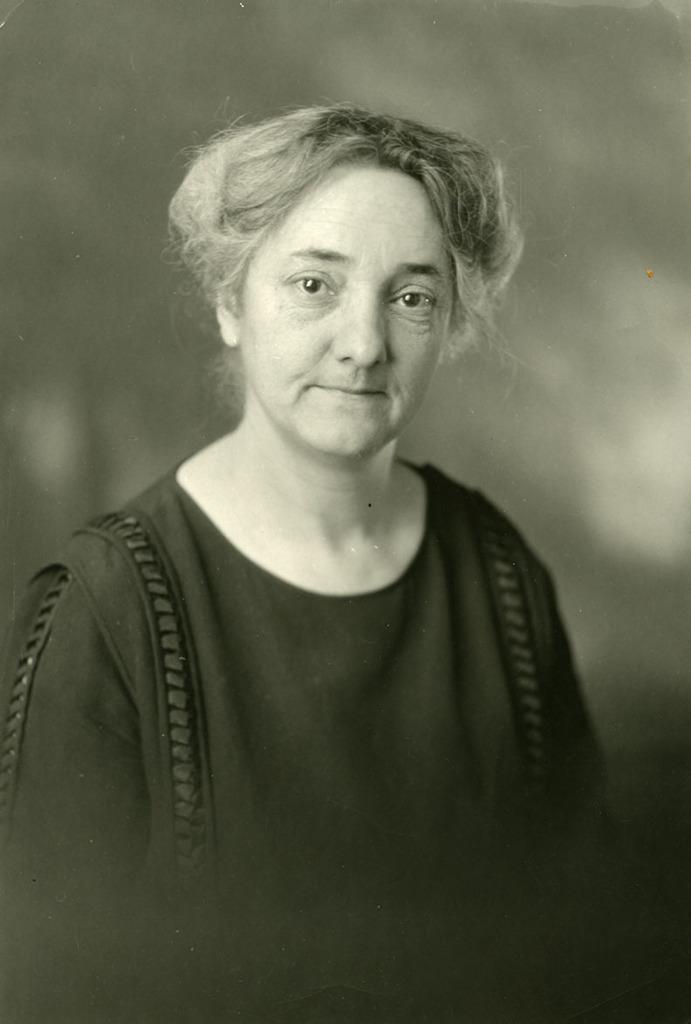Please provide a concise description of this image. There is a woman in the center of the image. 